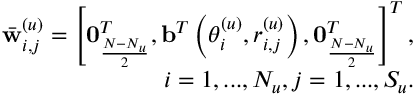Convert formula to latex. <formula><loc_0><loc_0><loc_500><loc_500>\begin{array} { r } { \bar { w } _ { i , j } ^ { ( u ) } = \left [ 0 _ { \frac { N - N _ { u } } { 2 } } ^ { T } , b ^ { T } \left ( \theta _ { i } ^ { ( u ) } , r _ { i , j } ^ { ( u ) } \right ) , 0 _ { \frac { N - N _ { u } } { 2 } } ^ { T } \right ] ^ { T } , } \\ { i = 1 , \dots , N _ { u } , j = 1 , \dots , S _ { u } . } \end{array}</formula> 